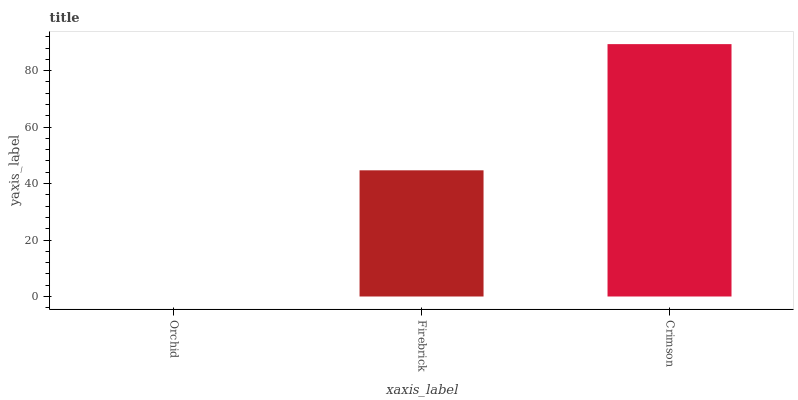Is Firebrick the minimum?
Answer yes or no. No. Is Firebrick the maximum?
Answer yes or no. No. Is Firebrick greater than Orchid?
Answer yes or no. Yes. Is Orchid less than Firebrick?
Answer yes or no. Yes. Is Orchid greater than Firebrick?
Answer yes or no. No. Is Firebrick less than Orchid?
Answer yes or no. No. Is Firebrick the high median?
Answer yes or no. Yes. Is Firebrick the low median?
Answer yes or no. Yes. Is Orchid the high median?
Answer yes or no. No. Is Crimson the low median?
Answer yes or no. No. 